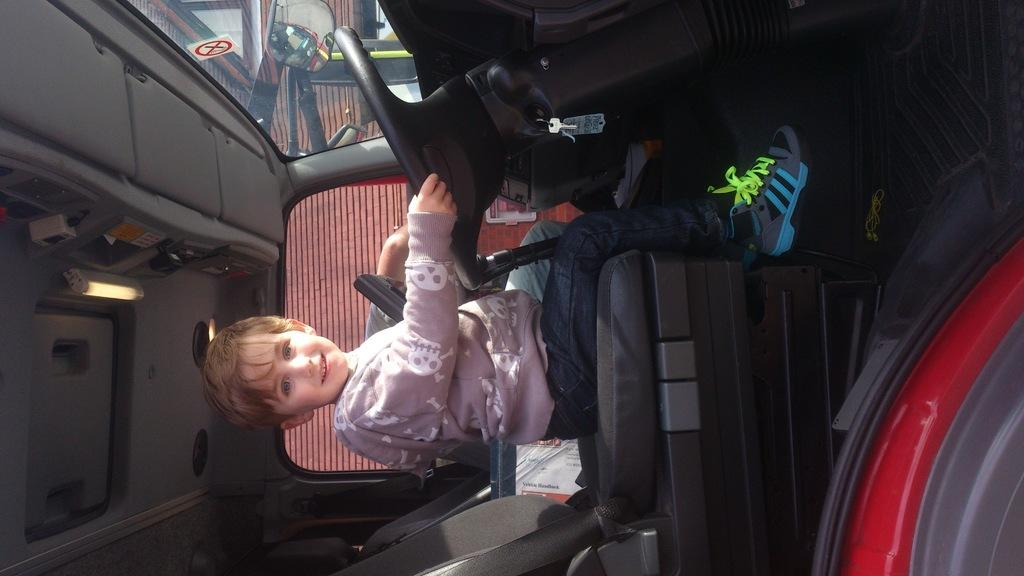What is the setting of the image? The image is of the inside of a vehicle. Who or what can be seen inside the vehicle? There is a boy sitting in the vehicle. What items are present in the vehicle? There are books present in the vehicle. What can be seen outside the vehicle through the windows? There is a building visible in the background through the vehicle's windows. What feature is present in the vehicle to help the driver see behind them? There are mirrors in the vehicle. How many servants are visible in the image? There are no servants present in the image; it is a picture of the inside of a vehicle with a boy and some books. What type of volleyball court can be seen through the vehicle's windows? There is no volleyball court visible in the image; it shows a building in the background. 